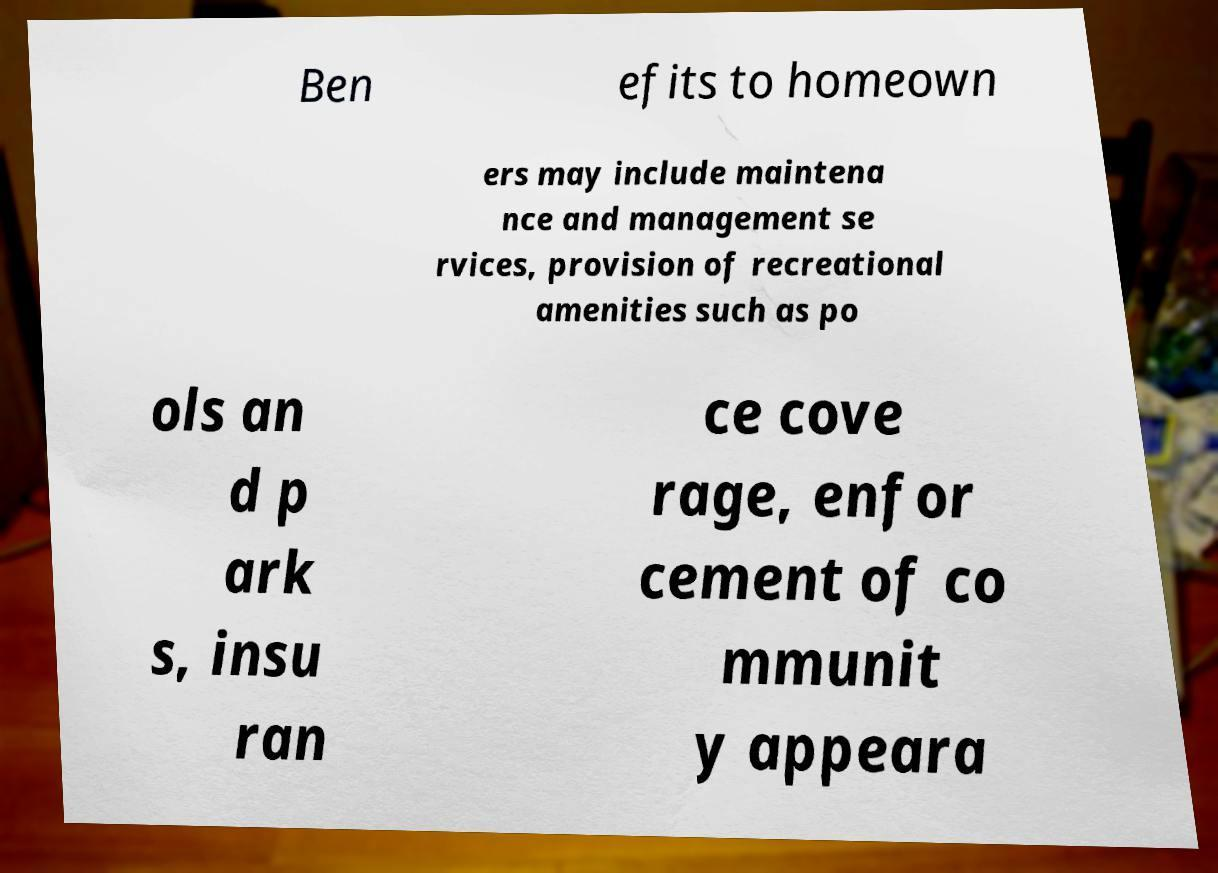Can you read and provide the text displayed in the image?This photo seems to have some interesting text. Can you extract and type it out for me? Ben efits to homeown ers may include maintena nce and management se rvices, provision of recreational amenities such as po ols an d p ark s, insu ran ce cove rage, enfor cement of co mmunit y appeara 